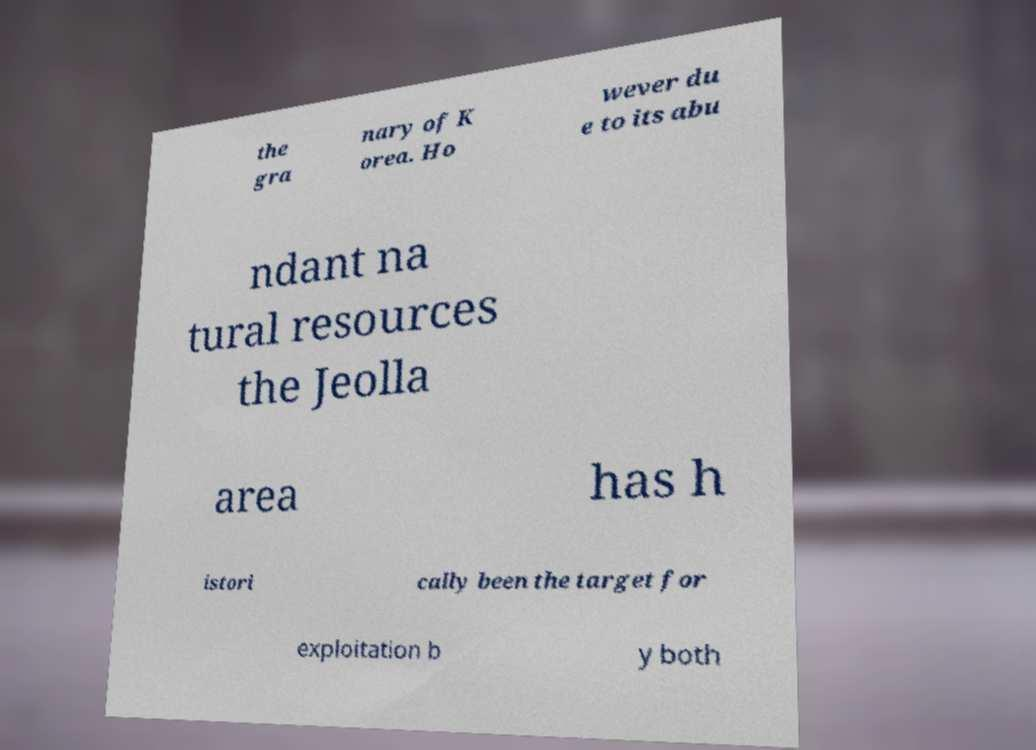What messages or text are displayed in this image? I need them in a readable, typed format. the gra nary of K orea. Ho wever du e to its abu ndant na tural resources the Jeolla area has h istori cally been the target for exploitation b y both 